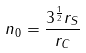Convert formula to latex. <formula><loc_0><loc_0><loc_500><loc_500>n _ { 0 } = \frac { 3 ^ { \frac { 1 } { 2 } } r _ { S } } { r _ { C } }</formula> 